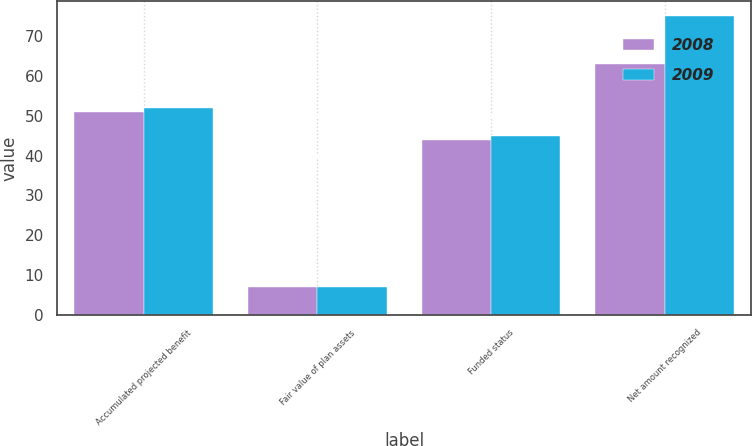Convert chart. <chart><loc_0><loc_0><loc_500><loc_500><stacked_bar_chart><ecel><fcel>Accumulated projected benefit<fcel>Fair value of plan assets<fcel>Funded status<fcel>Net amount recognized<nl><fcel>2008<fcel>51<fcel>7<fcel>44<fcel>63<nl><fcel>2009<fcel>52<fcel>7<fcel>45<fcel>75<nl></chart> 